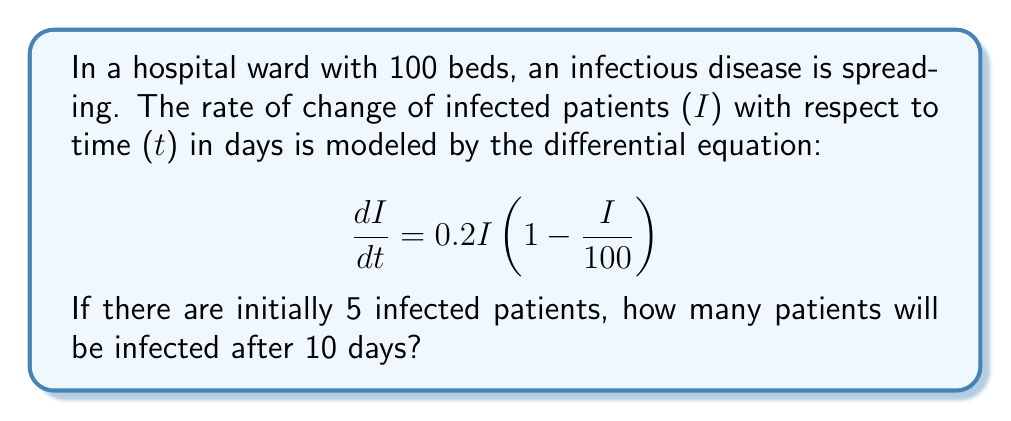Teach me how to tackle this problem. To solve this problem, we need to use the logistic growth model, which is a first-order differential equation. Let's approach this step-by-step:

1) The given differential equation is:

   $$\frac{dI}{dt} = 0.2I(1 - \frac{I}{100})$$

   This is a separable differential equation.

2) Separate the variables:

   $$\frac{dI}{I(1 - \frac{I}{100})} = 0.2dt$$

3) Integrate both sides:

   $$\int \frac{dI}{I(1 - \frac{I}{100})} = \int 0.2dt$$

4) The left side can be integrated using partial fractions:

   $$\ln|I| - \ln|100-I| = 0.2t + C$$

5) Simplify:

   $$\ln|\frac{I}{100-I}| = 0.2t + C$$

6) Take the exponential of both sides:

   $$\frac{I}{100-I} = Ae^{0.2t}$$, where $A = e^C$

7) Solve for I:

   $$I = \frac{100Ae^{0.2t}}{1 + Ae^{0.2t}}$$

8) Use the initial condition: At $t=0$, $I=5$:

   $$5 = \frac{100A}{1 + A}$$

   Solving this, we get $A = \frac{1}{19}$

9) Therefore, the solution is:

   $$I = \frac{100(\frac{1}{19})e^{0.2t}}{1 + (\frac{1}{19})e^{0.2t}} = \frac{100e^{0.2t}}{19 + e^{0.2t}}$$

10) To find I after 10 days, substitute $t=10$:

    $$I(10) = \frac{100e^{2}}{19 + e^{2}} \approx 83.85$$
Answer: After 10 days, approximately 84 patients will be infected. 